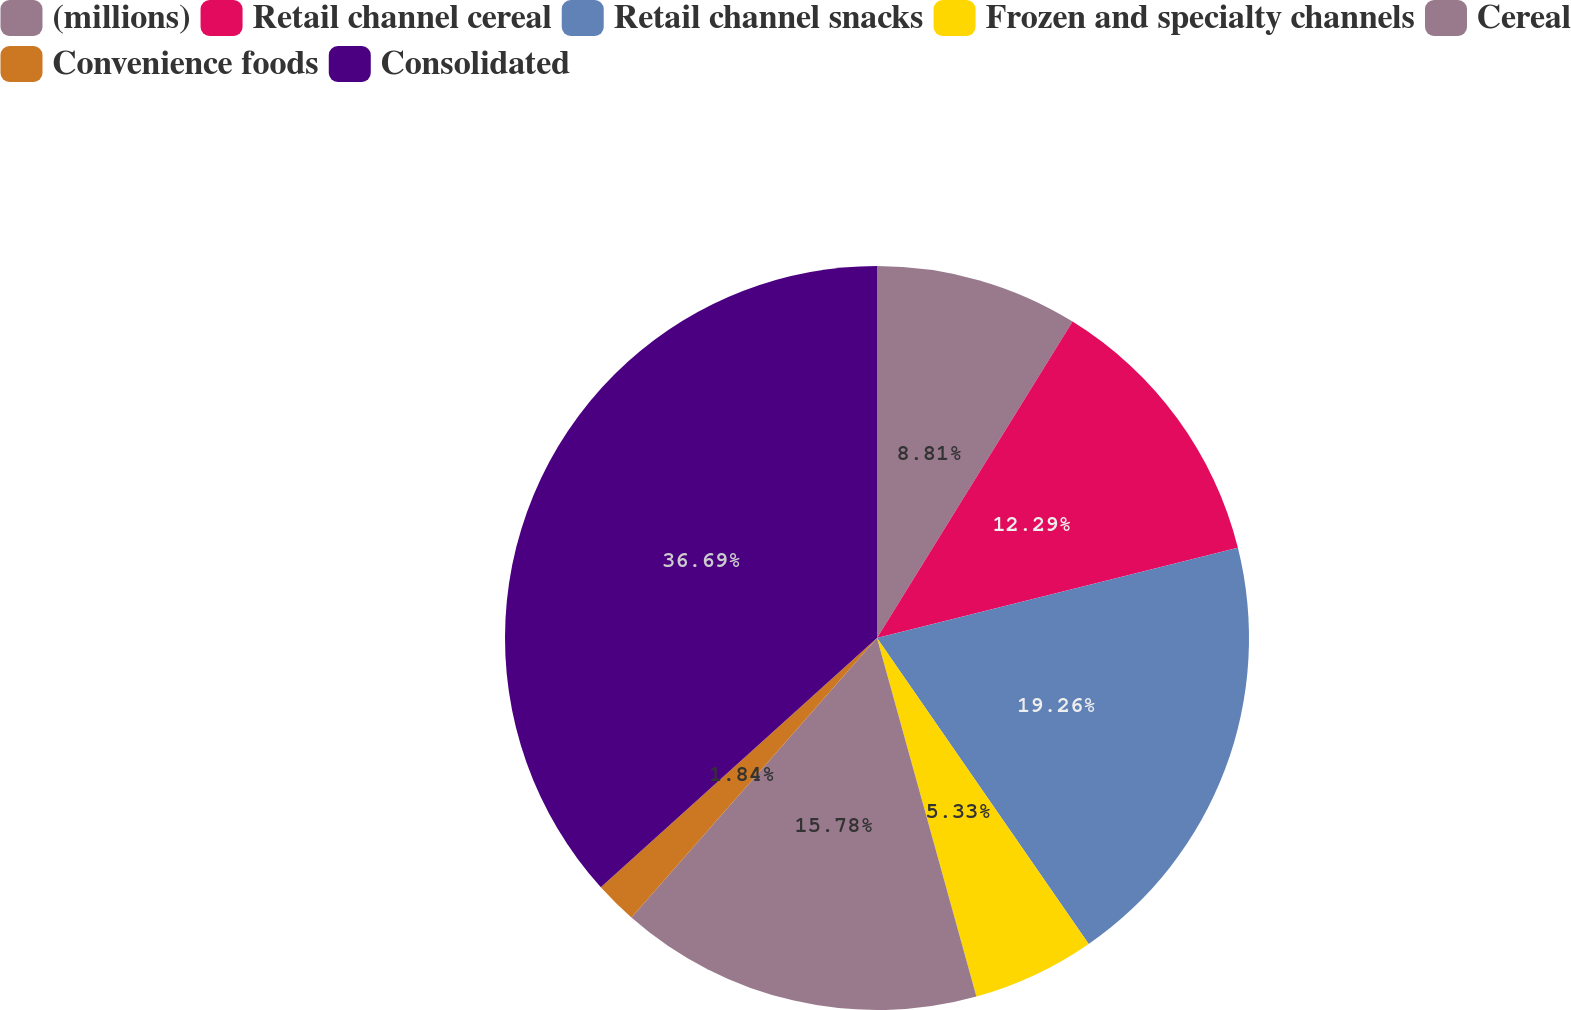Convert chart to OTSL. <chart><loc_0><loc_0><loc_500><loc_500><pie_chart><fcel>(millions)<fcel>Retail channel cereal<fcel>Retail channel snacks<fcel>Frozen and specialty channels<fcel>Cereal<fcel>Convenience foods<fcel>Consolidated<nl><fcel>8.81%<fcel>12.29%<fcel>19.26%<fcel>5.33%<fcel>15.78%<fcel>1.84%<fcel>36.68%<nl></chart> 